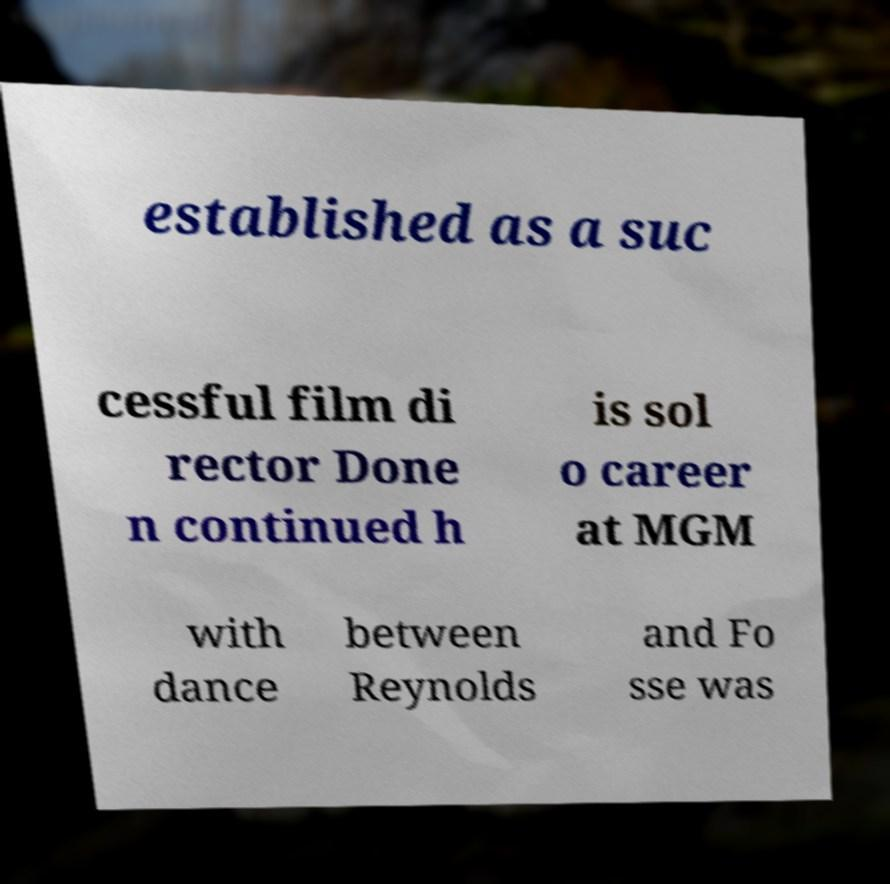Could you extract and type out the text from this image? established as a suc cessful film di rector Done n continued h is sol o career at MGM with dance between Reynolds and Fo sse was 